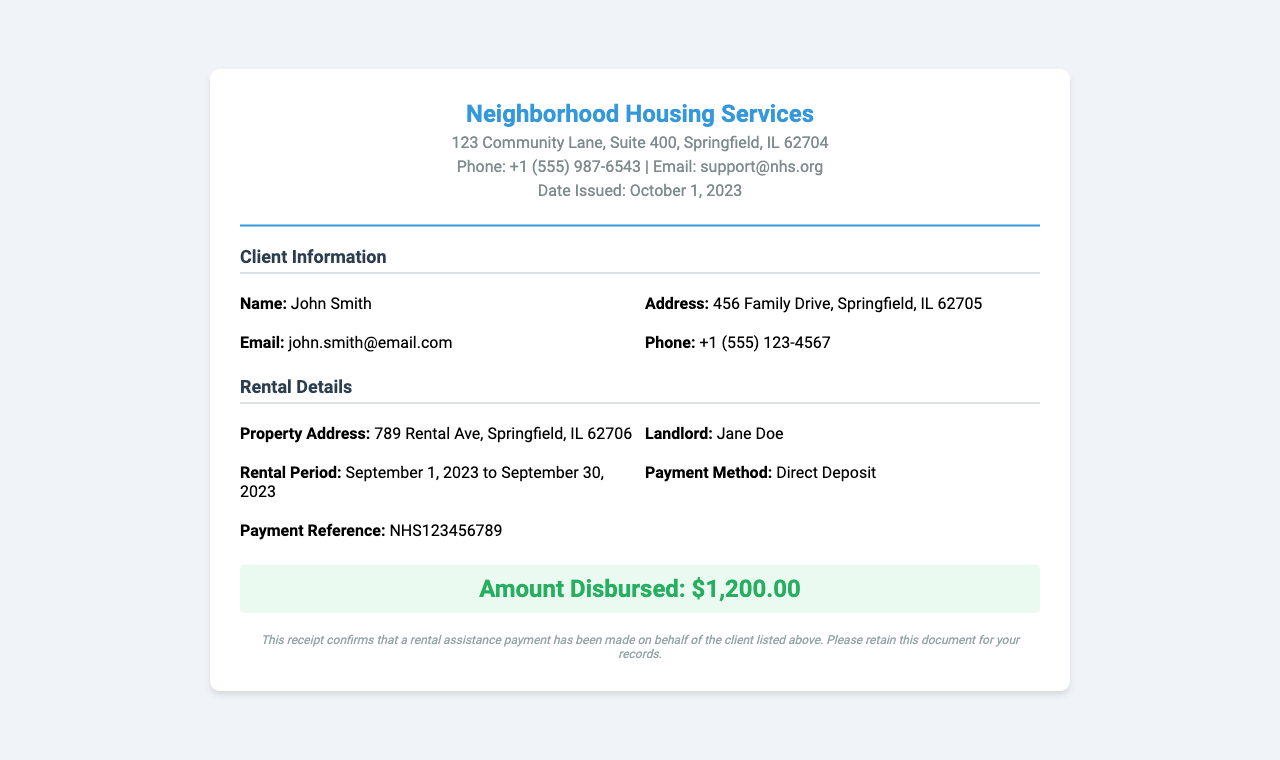What is the name of the client? The client's name is listed under Client Information in the document.
Answer: John Smith What is the rental period? The rental period is specified in the Rental Details section.
Answer: September 1, 2023 to September 30, 2023 What is the total amount disbursed? The total amount disbursed is highlighted prominently in the document.
Answer: $1,200.00 What is the property address? The property address is provided in the Rental Details section.
Answer: 789 Rental Ave, Springfield, IL 62706 What payment method was used? The payment method is indicated in the Rental Details section.
Answer: Direct Deposit Who is the landlord? The landlord's name is included in the Rental Details section.
Answer: Jane Doe When was the receipt issued? The issue date is found in the header of the document.
Answer: October 1, 2023 What is the contact email for Neighborhood Housing Services? The email address for contact is provided in the header section.
Answer: support@nhs.org What is the payment reference number? The payment reference number is mentioned in the Rental Details section.
Answer: NHS123456789 